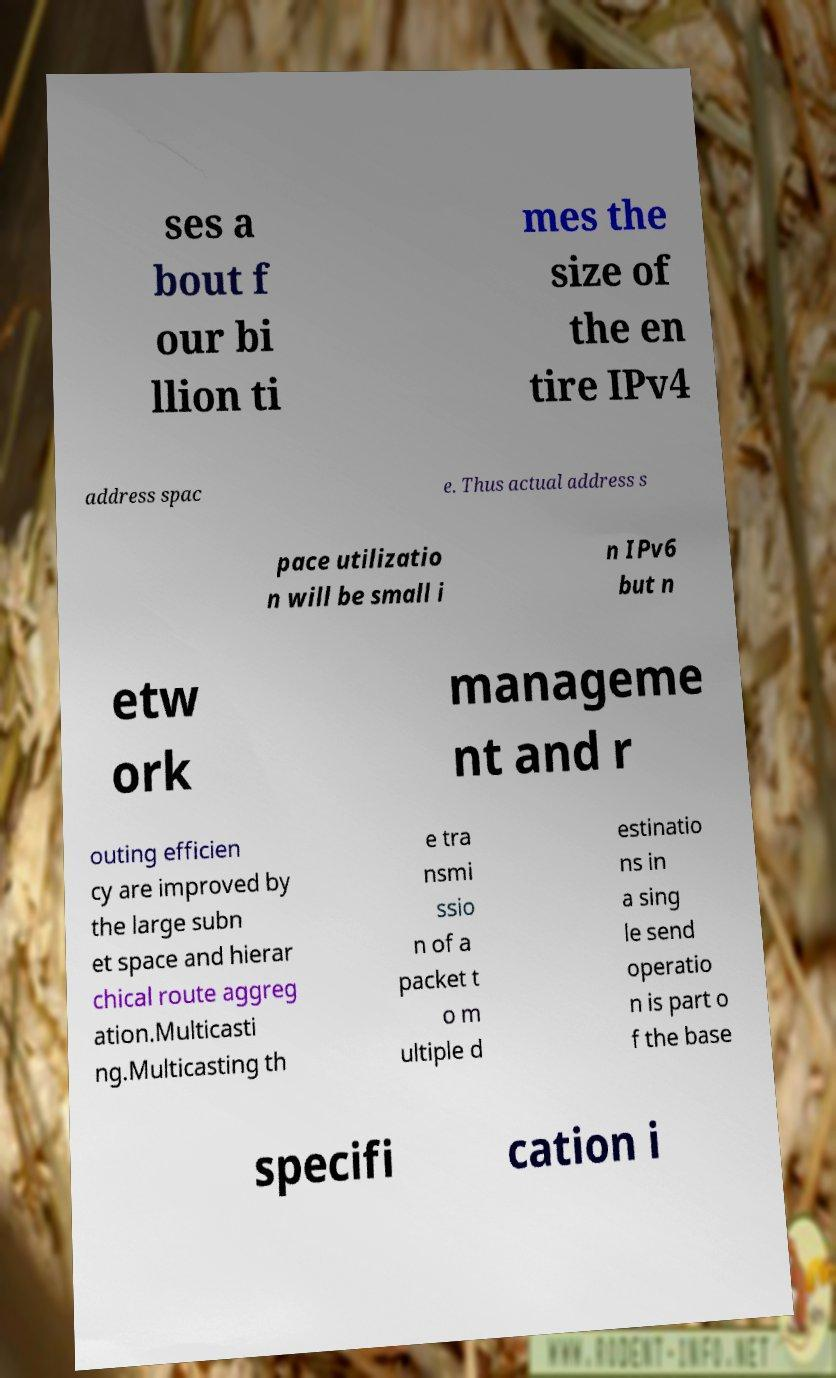Can you accurately transcribe the text from the provided image for me? ses a bout f our bi llion ti mes the size of the en tire IPv4 address spac e. Thus actual address s pace utilizatio n will be small i n IPv6 but n etw ork manageme nt and r outing efficien cy are improved by the large subn et space and hierar chical route aggreg ation.Multicasti ng.Multicasting th e tra nsmi ssio n of a packet t o m ultiple d estinatio ns in a sing le send operatio n is part o f the base specifi cation i 